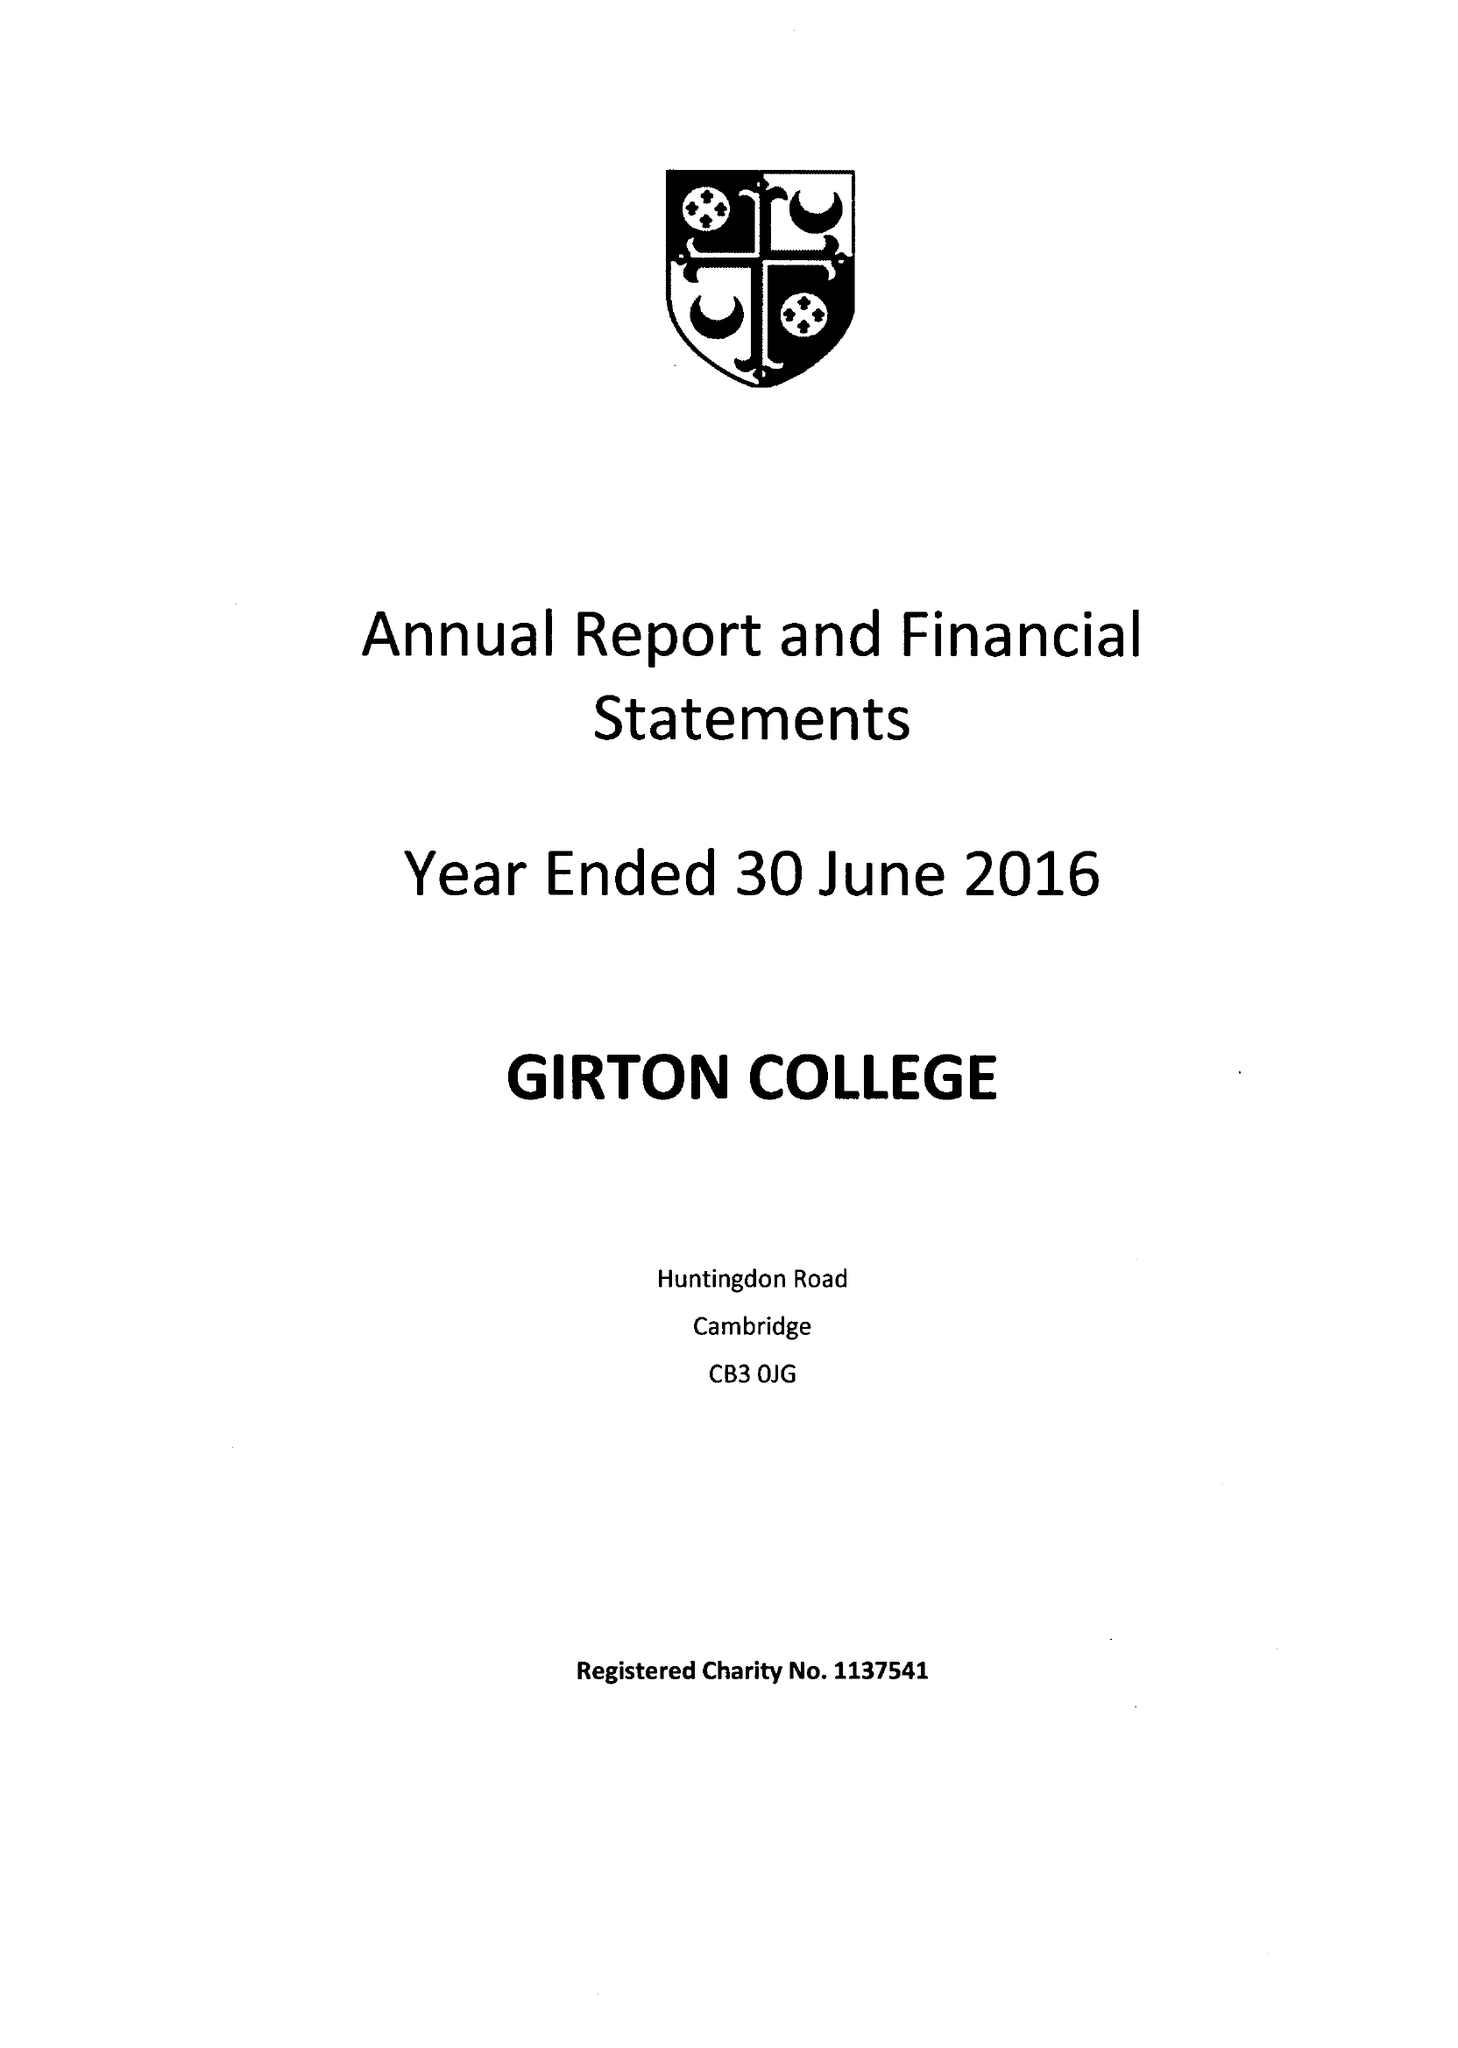What is the value for the address__post_town?
Answer the question using a single word or phrase. CAMBRIDGE 